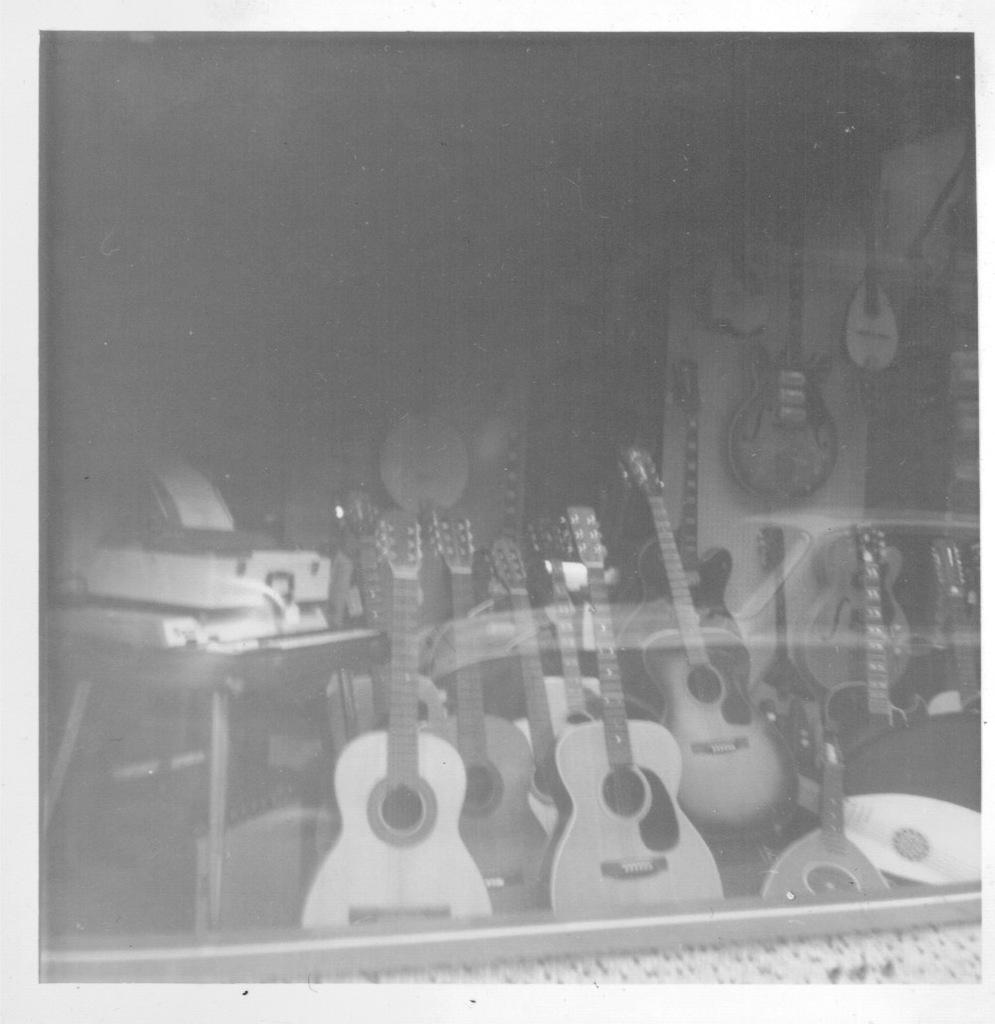What type of objects can be seen in the image? There are musical instruments in the image. What type of fold can be seen in the image? There is no fold present in the image; it only features musical instruments. 